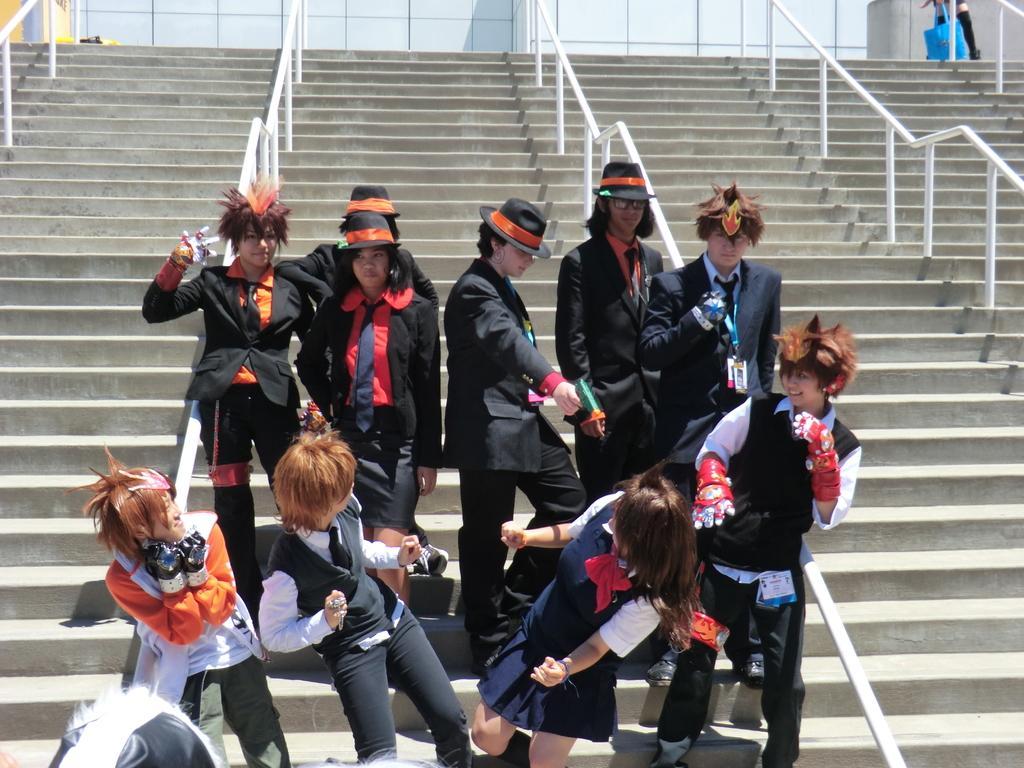In one or two sentences, can you explain what this image depicts? Here in this picture we can see number of people standing on the steps, which are present over there and we can see railings present in between them and we can also see some of them are wearing black colored jackets and hats on them. 